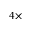<formula> <loc_0><loc_0><loc_500><loc_500>4 \times</formula> 